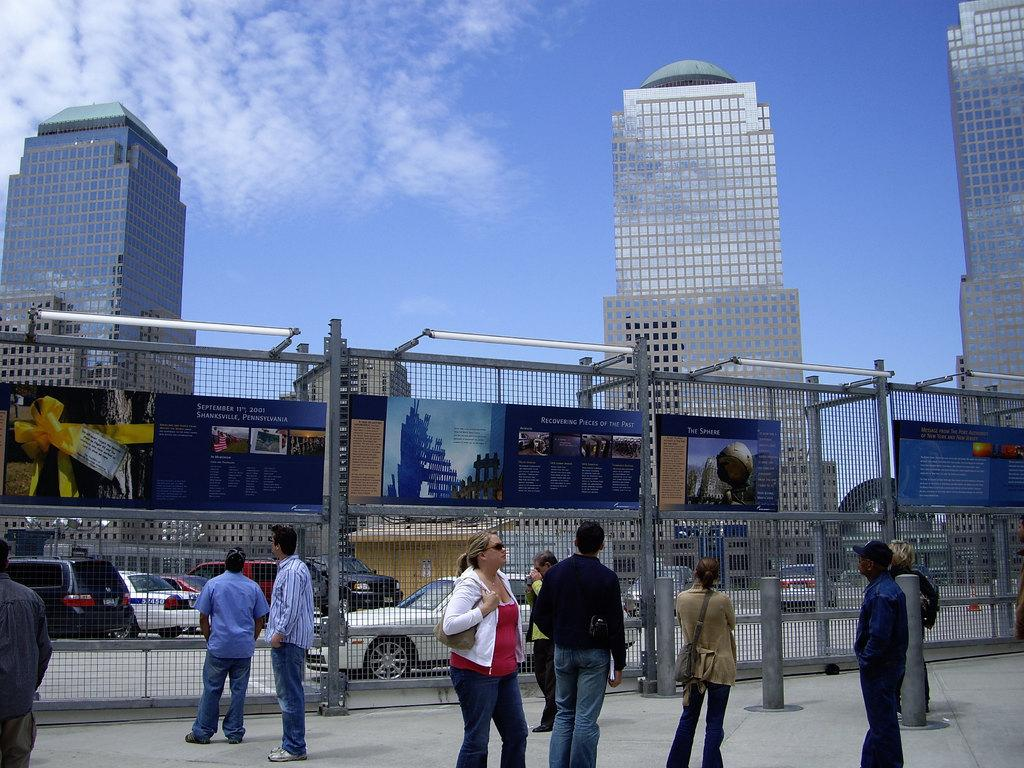Who or what can be seen in the image? There are people in the image. What is the fence with boards attached to it used for? The fence with boards attached to it is likely used as a barrier or boundary. What can be seen in the distance in the image? There are buildings, the sky, vehicles on the road, and other objects visible in the background of the image. Can you see an owl perched on the fence in the image? No, there is no owl present in the image. Are there any insects visible on the people in the image? No, there are no insects visible on the people in the image. 